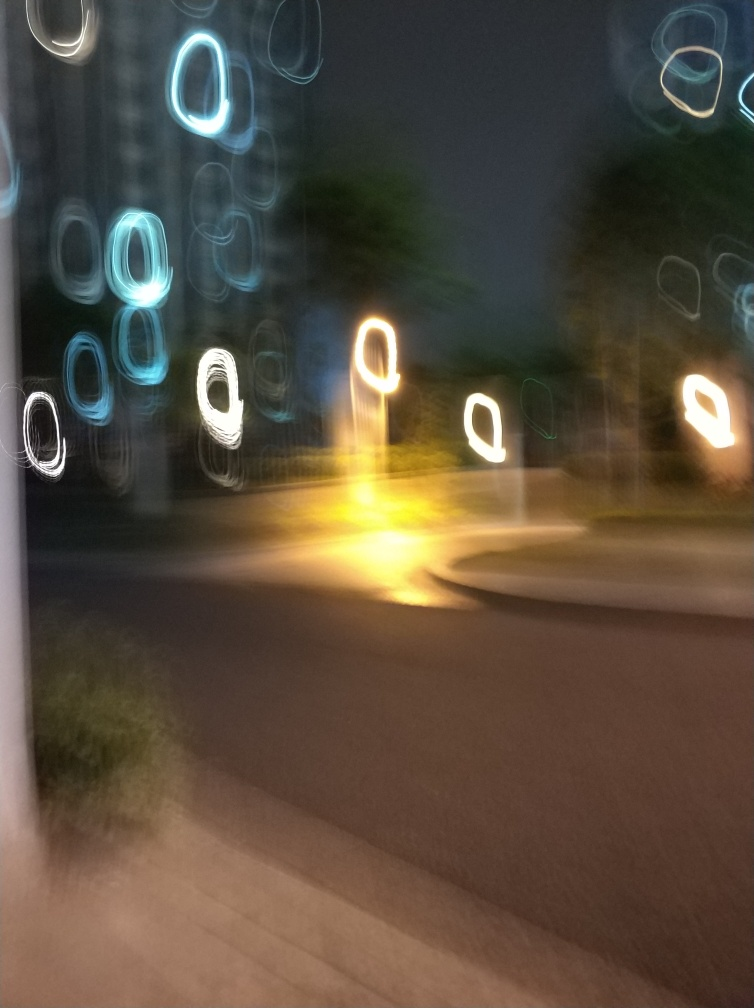Can you guess the possible cause of the blur and light patterns? The blur and distinctive light patterns suggest that the camera was either in motion while the shutter was open, or the photographic subject was moving rapidly in a low-light setting, leading to this motion blur effect. How could one recreate this effect intentionally? To intentionally recreate this effect, you'd need to use a slow shutter speed on the camera while moving it during the exposure. Alternatively, capturing light sources while moving the camera quickly in a dark setting could lead to these streams of light and abstract shapes. 